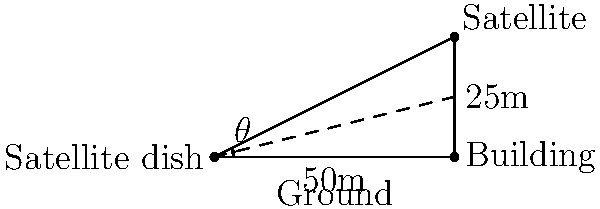As part of a secure satellite communication system upgrade, you need to determine the elevation angle for a new dish. The dish will be mounted on the ground next to a 50m tall building. The satellite it needs to communicate with is at an altitude of 25m above the top of the building. What is the elevation angle $\theta$ (in degrees) that the dish needs to be set at to directly face the satellite? To solve this problem, we'll use trigonometry, specifically the tangent function. Let's break it down step-by-step:

1) First, we need to identify the right triangle in the diagram. The right angle is at the base of the building.

2) The angle we're looking for, $\theta$, is the angle between the ground and the line of sight to the satellite.

3) In this right triangle:
   - The adjacent side is the distance from the dish to the building (50m)
   - The opposite side is the total height of the satellite (50m + 25m = 75m)

4) We can use the tangent function to find the angle:

   $$\tan(\theta) = \frac{\text{opposite}}{\text{adjacent}} = \frac{75}{50}$$

5) To solve for $\theta$, we need to use the inverse tangent (arctan or $\tan^{-1}$):

   $$\theta = \tan^{-1}(\frac{75}{50})$$

6) Using a calculator or computer:

   $$\theta = \tan^{-1}(1.5) \approx 56.31^\circ$$

7) Rounding to two decimal places:

   $$\theta \approx 56.31^\circ$$

Therefore, the elevation angle for the satellite dish should be set at approximately 56.31 degrees.
Answer: 56.31° 